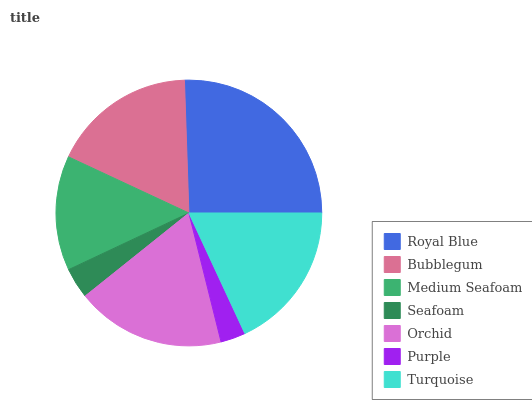Is Purple the minimum?
Answer yes or no. Yes. Is Royal Blue the maximum?
Answer yes or no. Yes. Is Bubblegum the minimum?
Answer yes or no. No. Is Bubblegum the maximum?
Answer yes or no. No. Is Royal Blue greater than Bubblegum?
Answer yes or no. Yes. Is Bubblegum less than Royal Blue?
Answer yes or no. Yes. Is Bubblegum greater than Royal Blue?
Answer yes or no. No. Is Royal Blue less than Bubblegum?
Answer yes or no. No. Is Bubblegum the high median?
Answer yes or no. Yes. Is Bubblegum the low median?
Answer yes or no. Yes. Is Turquoise the high median?
Answer yes or no. No. Is Orchid the low median?
Answer yes or no. No. 